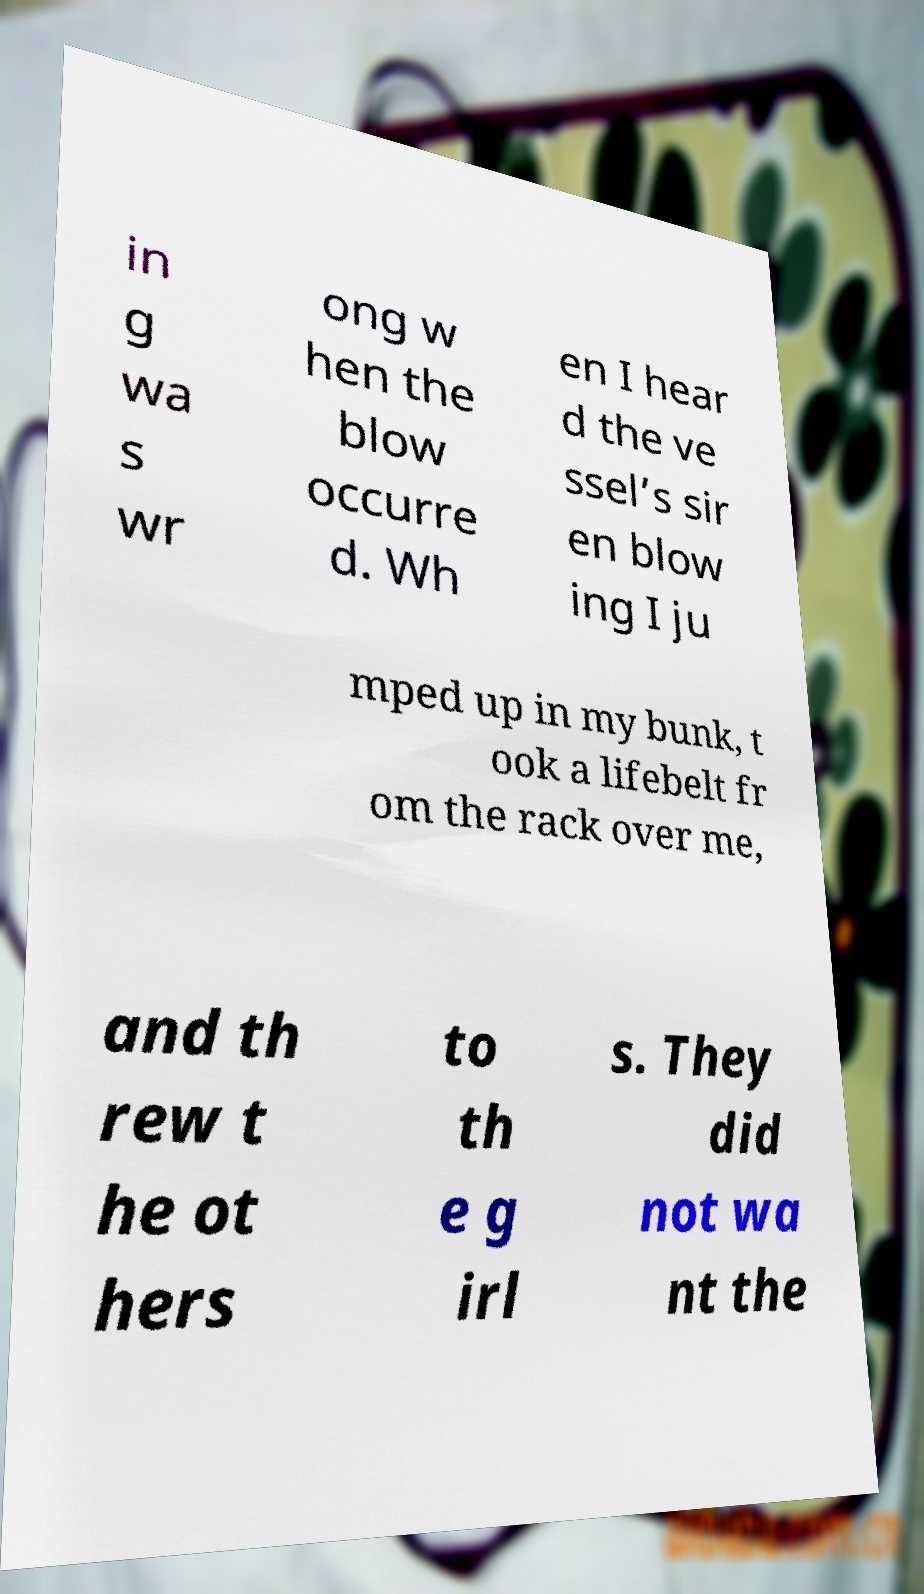There's text embedded in this image that I need extracted. Can you transcribe it verbatim? in g wa s wr ong w hen the blow occurre d. Wh en I hear d the ve ssel’s sir en blow ing I ju mped up in my bunk, t ook a lifebelt fr om the rack over me, and th rew t he ot hers to th e g irl s. They did not wa nt the 